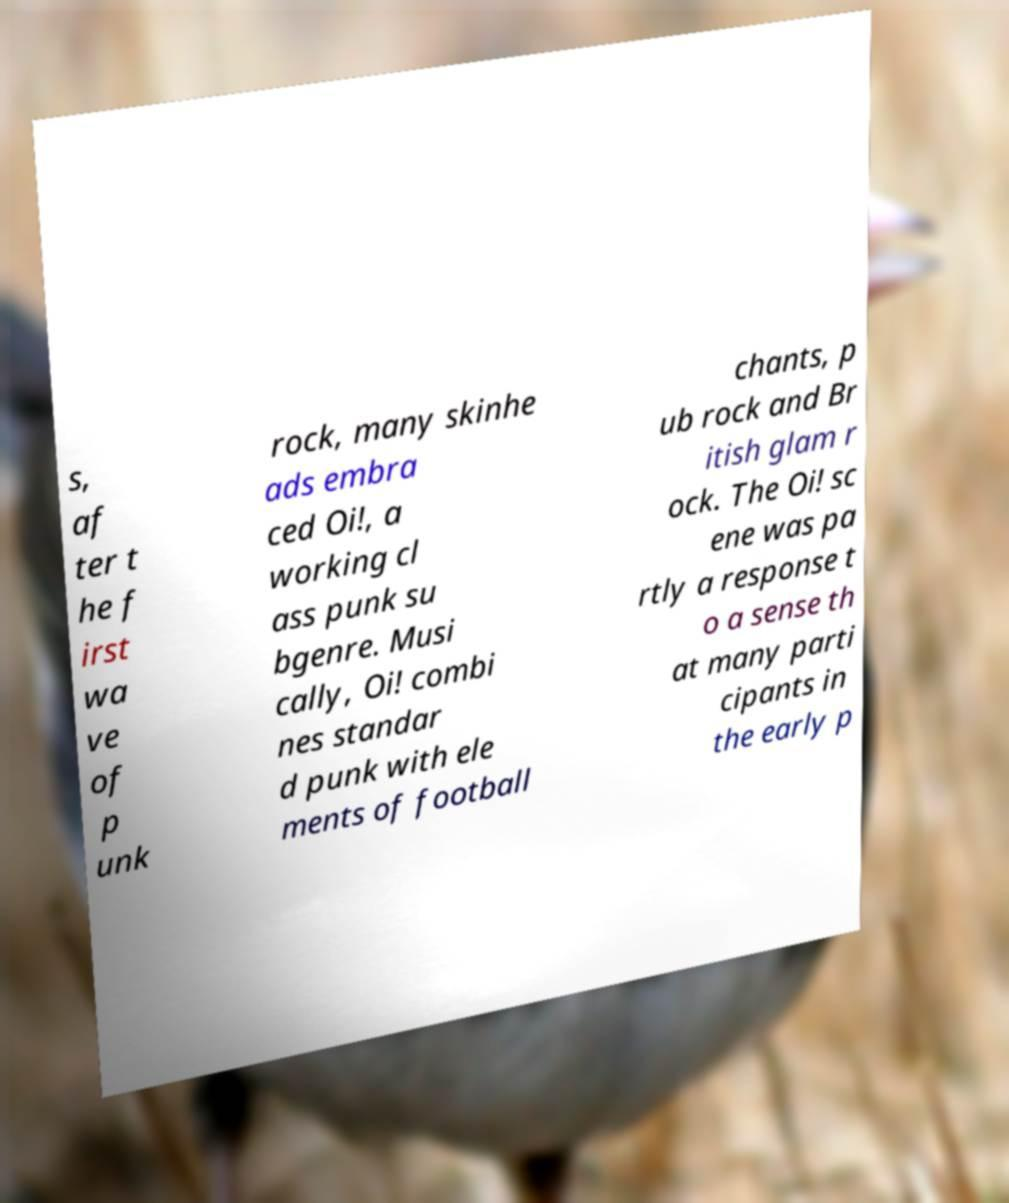Please identify and transcribe the text found in this image. s, af ter t he f irst wa ve of p unk rock, many skinhe ads embra ced Oi!, a working cl ass punk su bgenre. Musi cally, Oi! combi nes standar d punk with ele ments of football chants, p ub rock and Br itish glam r ock. The Oi! sc ene was pa rtly a response t o a sense th at many parti cipants in the early p 